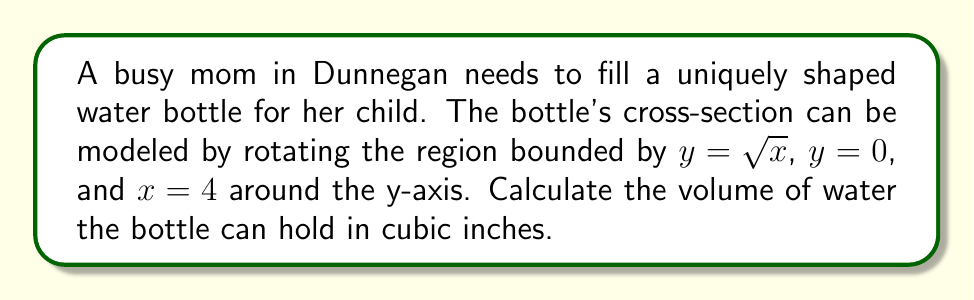Can you solve this math problem? To solve this problem, we'll use the washer method to calculate the volume of the solid formed by rotation.

Step 1: Identify the functions and limits
- Outer function: $r(y) = y^2$ (solve $y = \sqrt{x}$ for x)
- Inner function: $R = 0$ (y-axis)
- Lower limit: $y = 0$
- Upper limit: $y = 2$ (when $x = 4$, $y = \sqrt{4} = 2$)

Step 2: Set up the integral
The washer method formula is:
$$V = \pi \int_a^b [R(y)^2 - r(y)^2] dy$$

Substituting our functions and limits:
$$V = \pi \int_0^2 [0^2 - (y^2)^2] dy$$

Step 3: Simplify the integrand
$$V = \pi \int_0^2 [-y^4] dy$$

Step 4: Integrate
$$V = \pi \left[-\frac{1}{5}y^5\right]_0^2$$

Step 5: Evaluate the definite integral
$$V = \pi \left[-\frac{1}{5}(2^5) - \left(-\frac{1}{5}(0^5)\right)\right]$$
$$V = \pi \left[-\frac{32}{5}\right]$$

Step 6: Calculate the final result
$$V = -\frac{32\pi}{5} \approx 20.11 \text{ cubic inches}$$
Answer: $\frac{32\pi}{5}$ cubic inches 